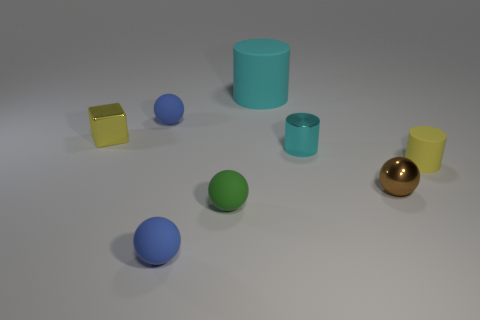How many spheres are present and what colors are they? There are five spheres in the image, and their colors are blue, green, another blue with a darker hue, yellow, and one that appears to be gold or bronze.  Are there any other shapes besides spheres and a cylinder? Yes, aside from the spheres and the large cyan cylinder, there is also a yellow cube in the image. 